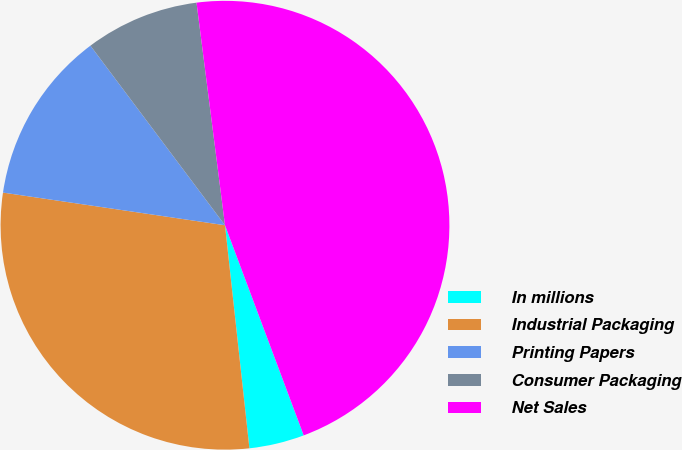Convert chart. <chart><loc_0><loc_0><loc_500><loc_500><pie_chart><fcel>In millions<fcel>Industrial Packaging<fcel>Printing Papers<fcel>Consumer Packaging<fcel>Net Sales<nl><fcel>3.97%<fcel>29.06%<fcel>12.44%<fcel>8.21%<fcel>46.32%<nl></chart> 